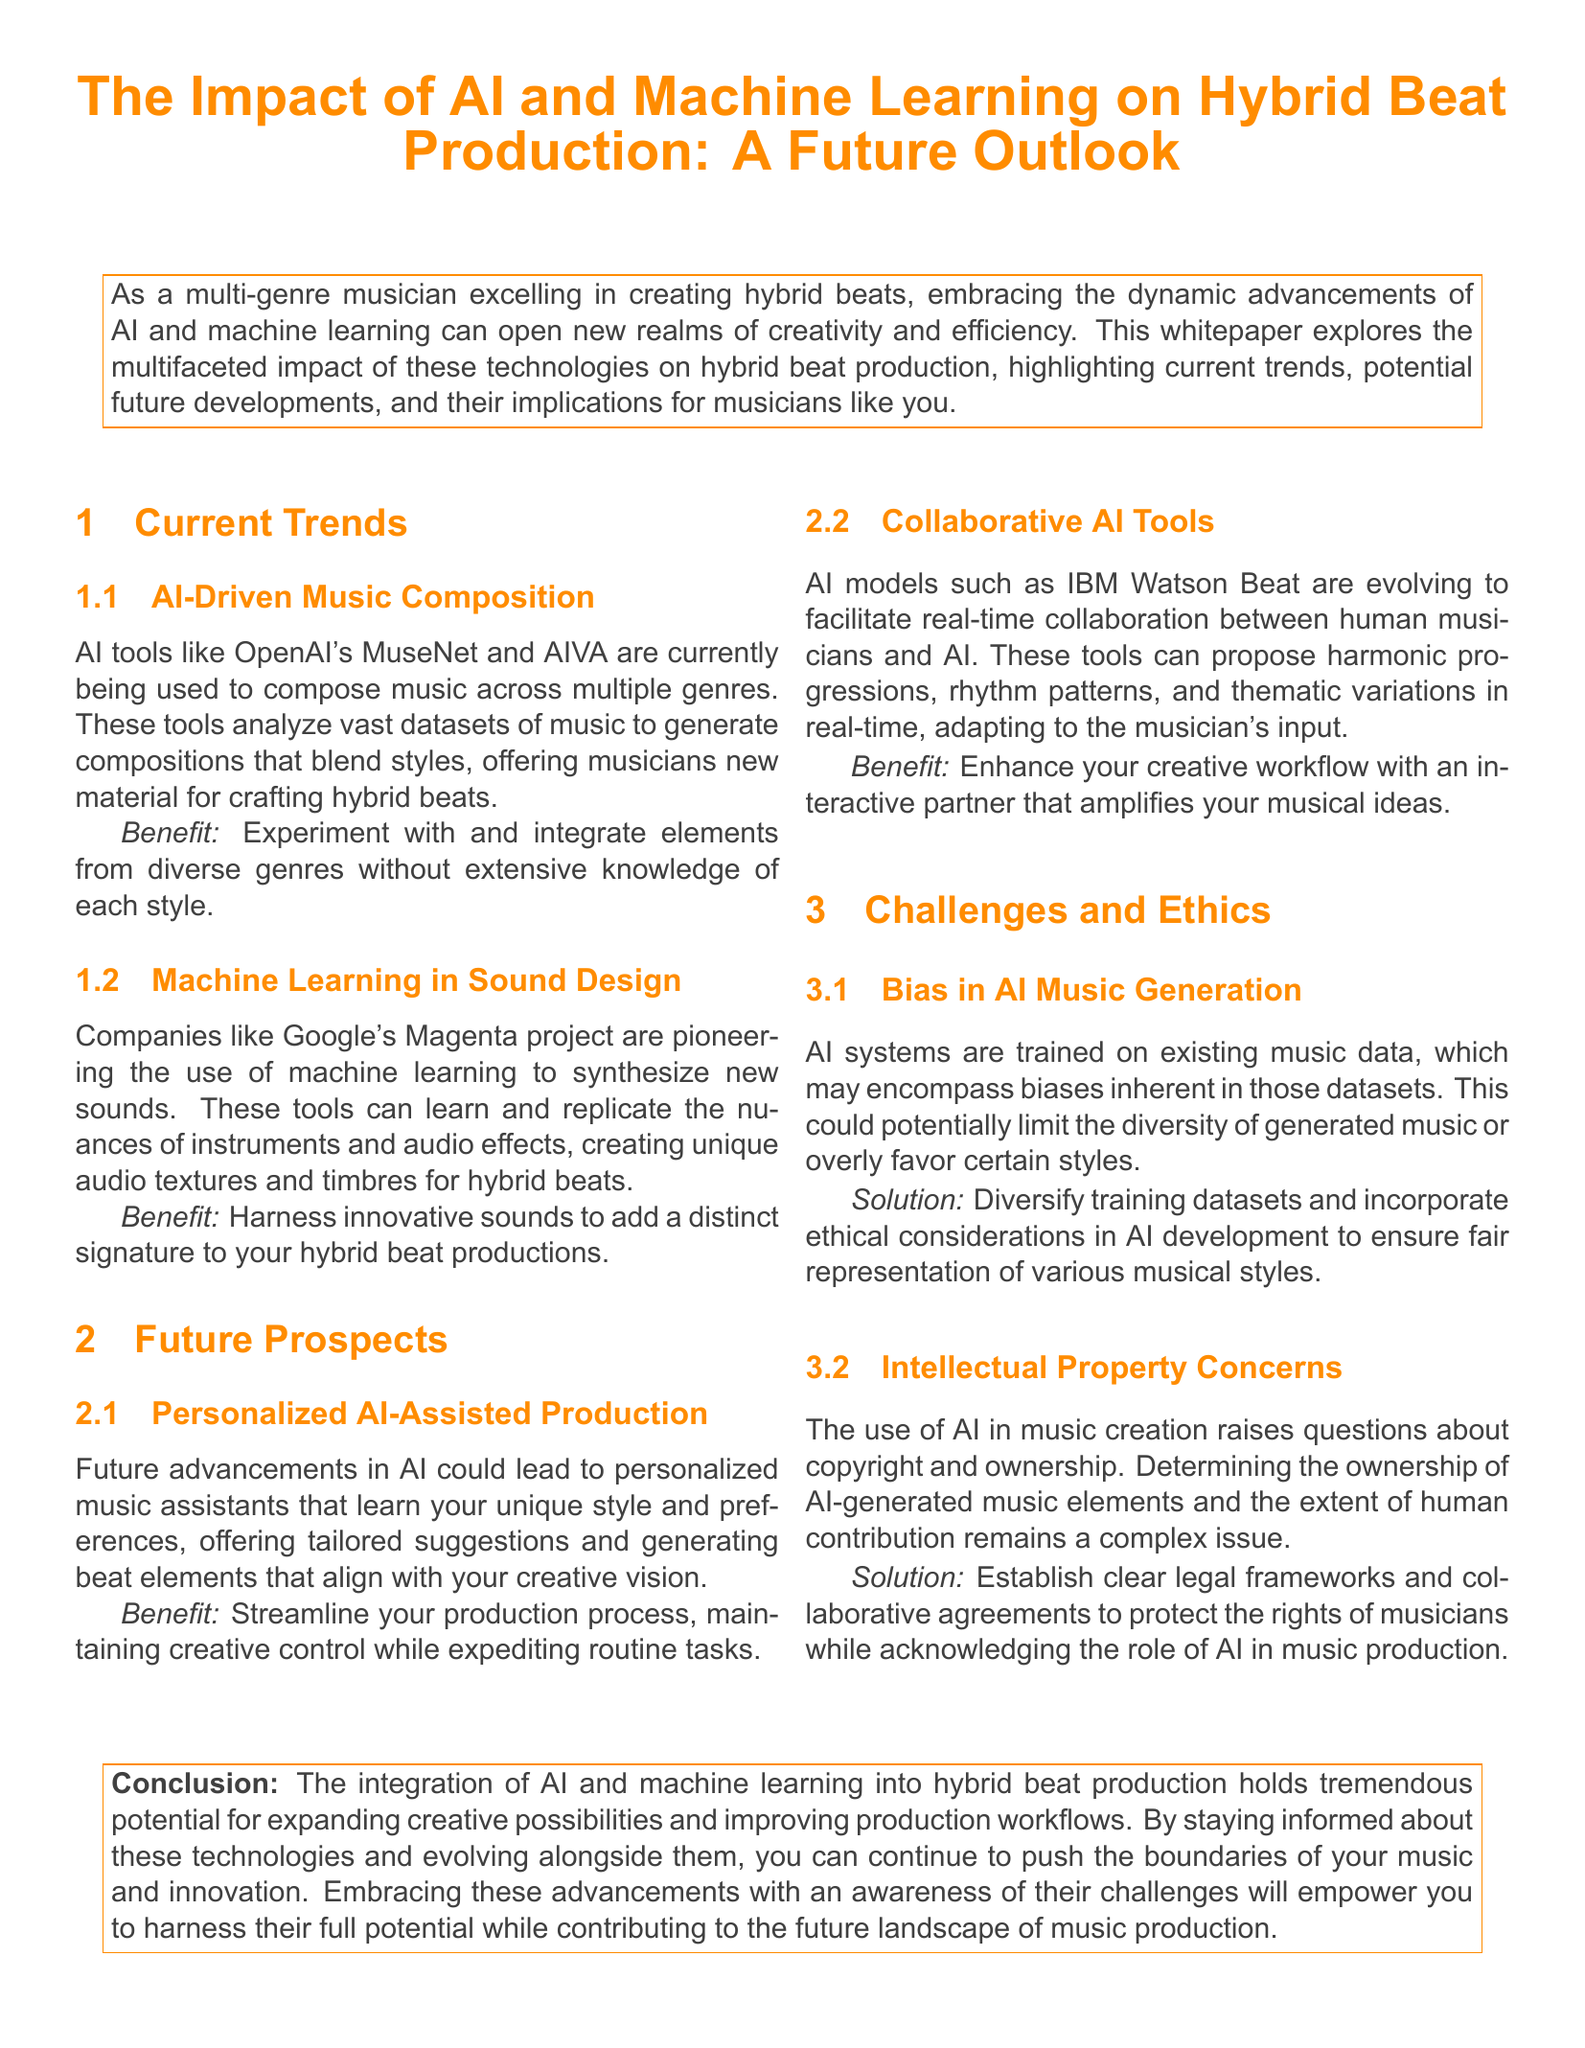What are some AI tools used in music composition? The document lists tools such as OpenAI's MuseNet and AIVA that are currently being used for music composition across multiple genres.
Answer: MuseNet, AIVA What project is mentioned for machine learning in sound design? The document references Google's Magenta project as a pioneer in using machine learning for sound design.
Answer: Magenta What could future AI advancements lead to in music production? The whitepaper discusses personalized AI-assisted production as a potential future advancement.
Answer: Personalized AI-Assisted Production What is a key benefit of AI-driven music composition? The document states that musicians can experiment and integrate diverse genre elements with AI-driven music composition.
Answer: Experiment with diverse genres What ethical concern is raised regarding AI in music creation? The whitepaper discusses bias in AI music generation as a significant ethical concern.
Answer: Bias What solution is proposed to address bias in AI music generation? The document suggests diversifying training datasets and incorporating ethical considerations.
Answer: Diversify training datasets What is IBM Watson Beat evolving to facilitate? The document mentions that IBM Watson Beat is evolving to facilitate real-time collaboration between human musicians and AI.
Answer: Real-time collaboration What issue related to AI-generated music is explored in the document? The document explores intellectual property concerns regarding AI-generated music and ownership.
Answer: Intellectual Property Concerns What is the conclusion regarding the integration of AI in music production? The conclusion emphasizes that integrating AI into hybrid beat production expands creative possibilities and improves workflows.
Answer: Expands creative possibilities 